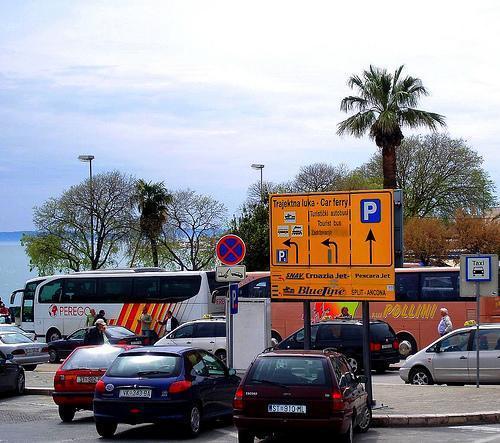How many palm trees are in the picture?
Give a very brief answer. 2. 